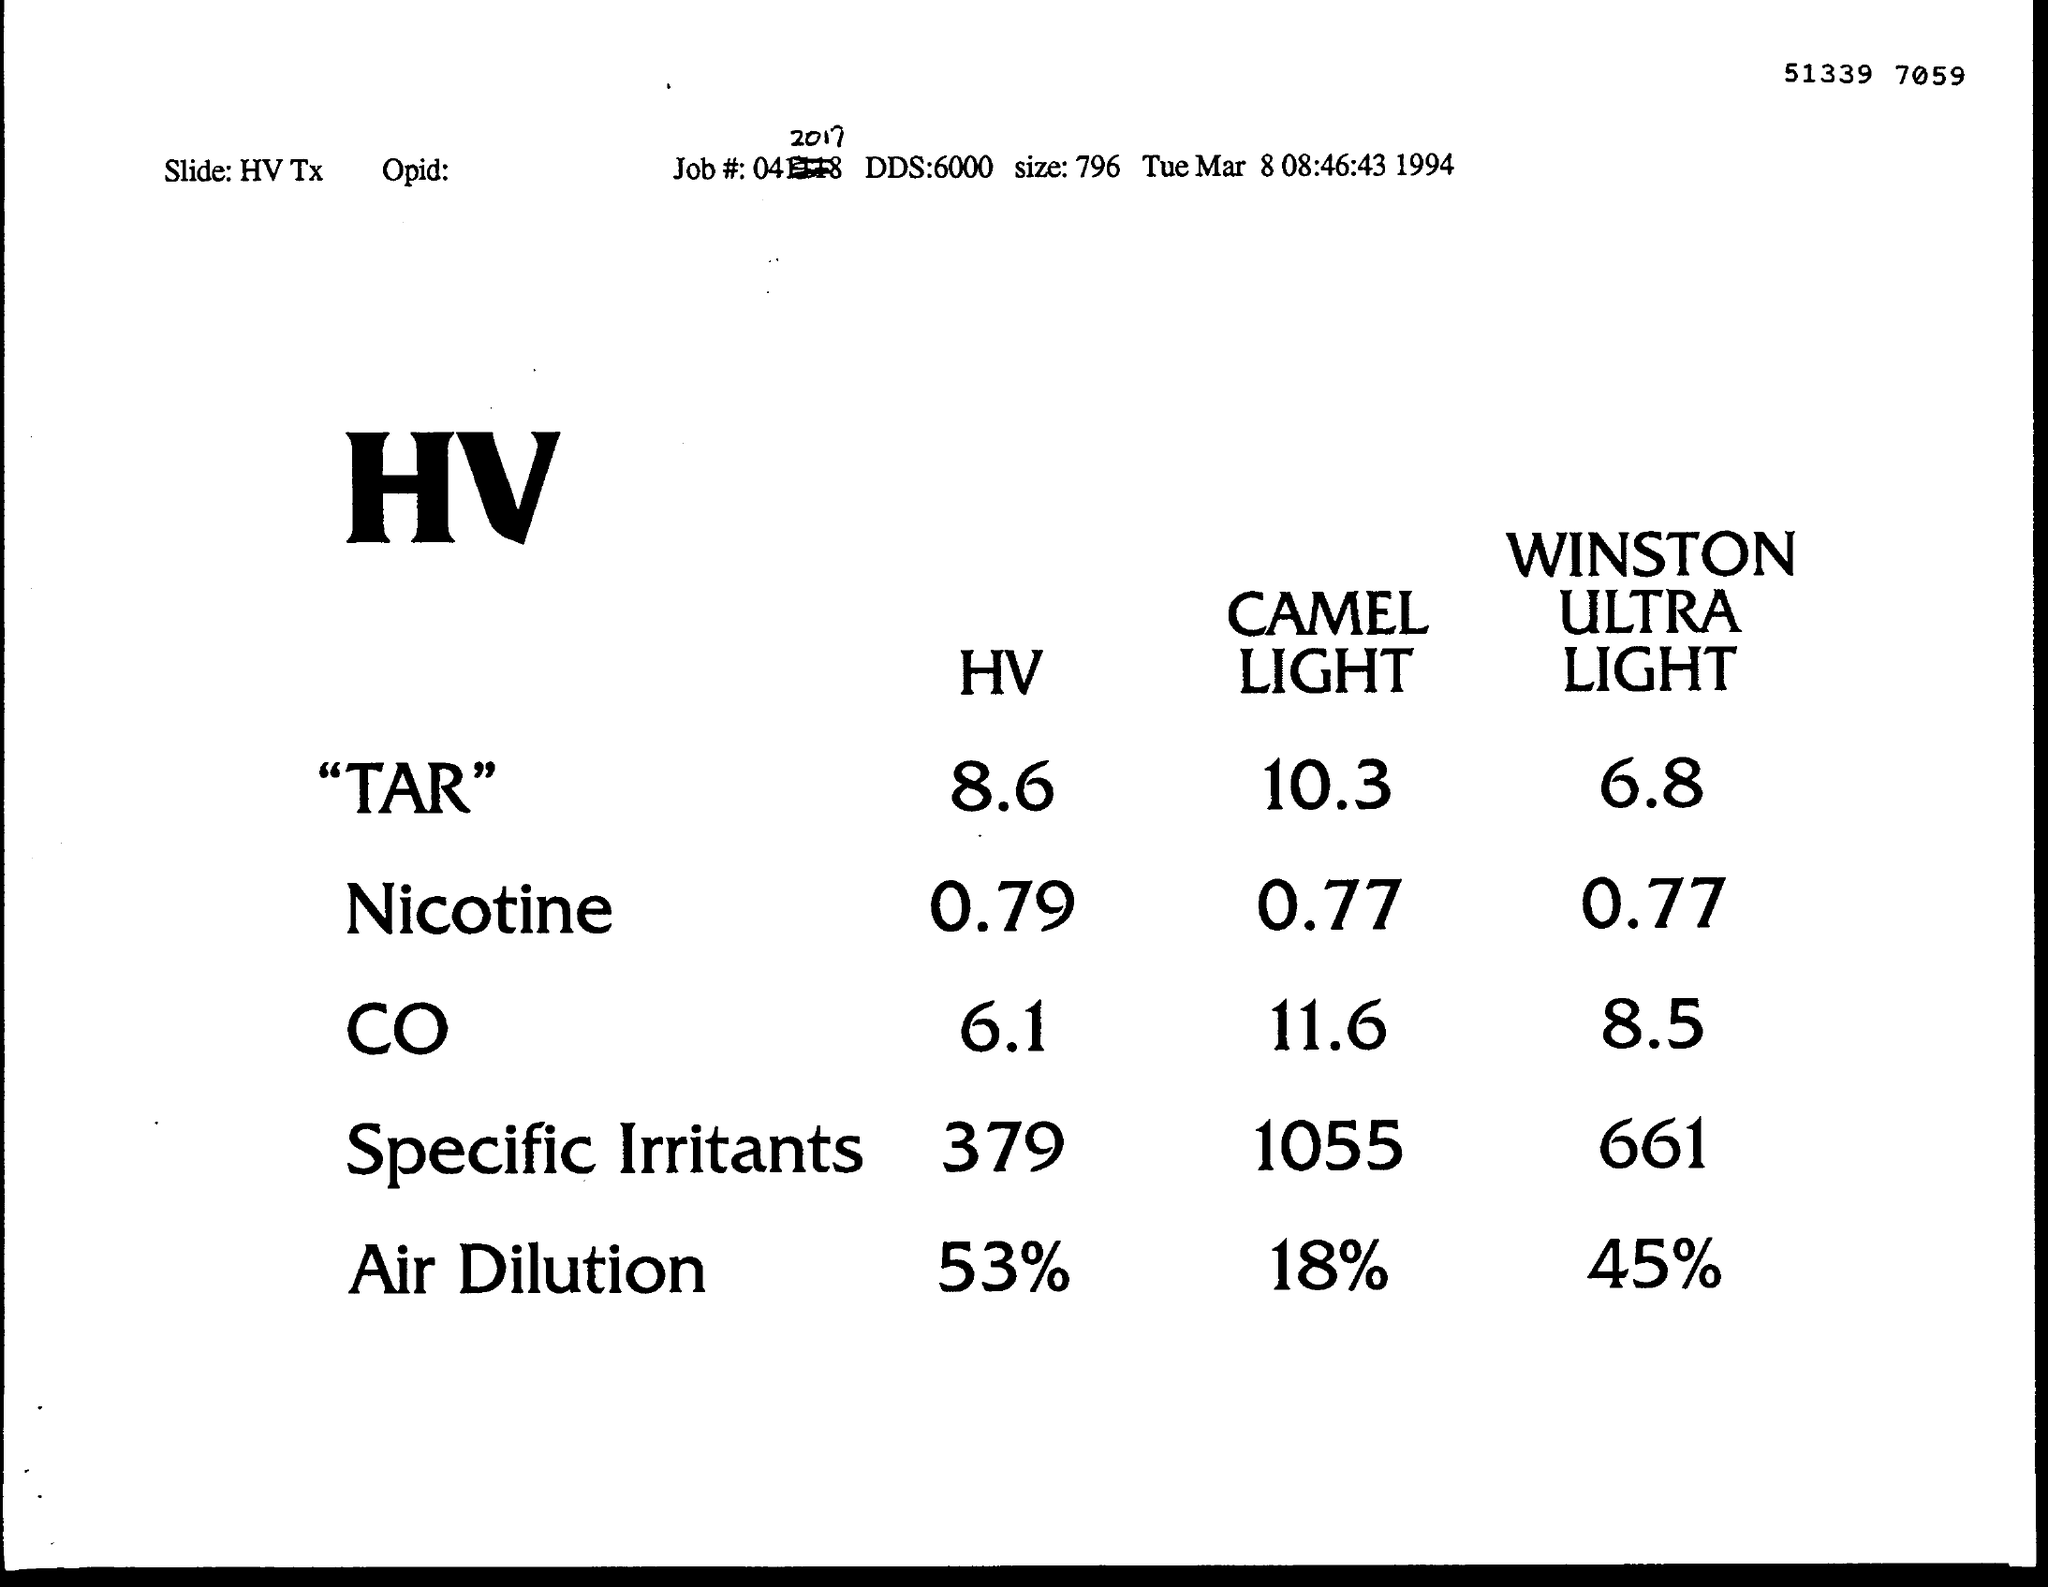Give some essential details in this illustration. The HV (hazard value) for specific irritants is 379. The HV of Air Dilution is 53%. The size mentioned is 796... The year mentioned is 1994. The time mentioned is 08:46:43. 